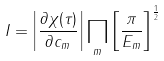Convert formula to latex. <formula><loc_0><loc_0><loc_500><loc_500>I = \left | \frac { \partial \chi ( \tau ) } { \partial c _ { m } } \right | \prod _ { m } \left [ \frac { \pi } { E _ { m } } \right ] ^ { \frac { 1 } { 2 } }</formula> 